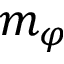<formula> <loc_0><loc_0><loc_500><loc_500>m _ { \varphi }</formula> 